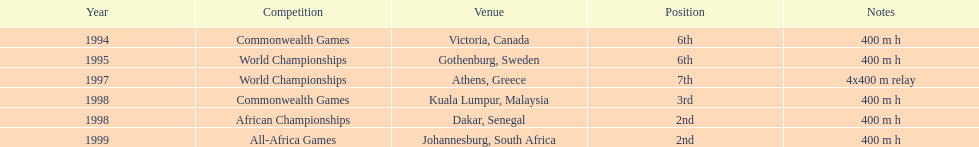What was the duration of the relay in the 1997 world championships where ken harden participated? 4x400 m relay. 